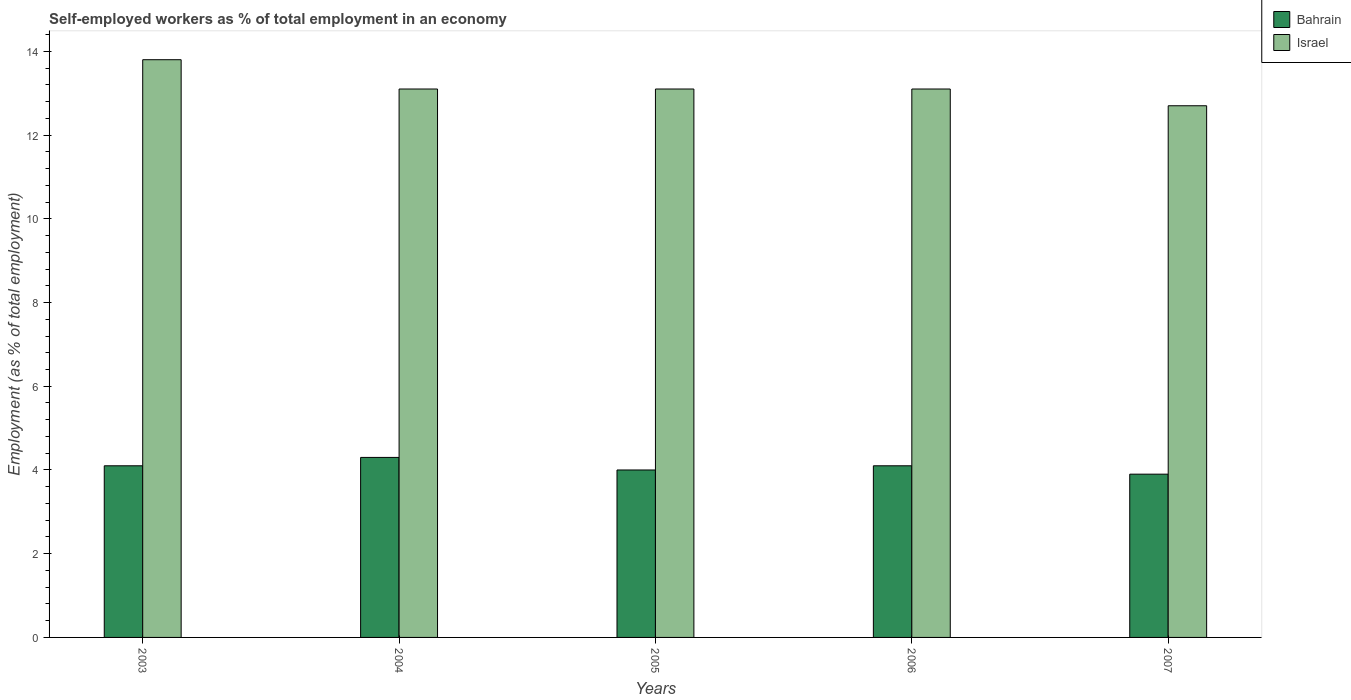Are the number of bars per tick equal to the number of legend labels?
Offer a very short reply. Yes. How many bars are there on the 1st tick from the left?
Your answer should be very brief. 2. What is the percentage of self-employed workers in Israel in 2003?
Provide a short and direct response. 13.8. Across all years, what is the maximum percentage of self-employed workers in Israel?
Provide a succinct answer. 13.8. Across all years, what is the minimum percentage of self-employed workers in Bahrain?
Give a very brief answer. 3.9. In which year was the percentage of self-employed workers in Bahrain maximum?
Give a very brief answer. 2004. In which year was the percentage of self-employed workers in Bahrain minimum?
Ensure brevity in your answer.  2007. What is the total percentage of self-employed workers in Bahrain in the graph?
Your response must be concise. 20.4. What is the difference between the percentage of self-employed workers in Bahrain in 2004 and that in 2007?
Offer a terse response. 0.4. What is the difference between the percentage of self-employed workers in Bahrain in 2007 and the percentage of self-employed workers in Israel in 2004?
Your response must be concise. -9.2. What is the average percentage of self-employed workers in Bahrain per year?
Ensure brevity in your answer.  4.08. In the year 2003, what is the difference between the percentage of self-employed workers in Israel and percentage of self-employed workers in Bahrain?
Your answer should be very brief. 9.7. What is the ratio of the percentage of self-employed workers in Bahrain in 2006 to that in 2007?
Offer a terse response. 1.05. Is the difference between the percentage of self-employed workers in Israel in 2003 and 2007 greater than the difference between the percentage of self-employed workers in Bahrain in 2003 and 2007?
Keep it short and to the point. Yes. What is the difference between the highest and the second highest percentage of self-employed workers in Israel?
Offer a very short reply. 0.7. What is the difference between the highest and the lowest percentage of self-employed workers in Bahrain?
Provide a short and direct response. 0.4. Is the sum of the percentage of self-employed workers in Israel in 2004 and 2007 greater than the maximum percentage of self-employed workers in Bahrain across all years?
Give a very brief answer. Yes. What does the 1st bar from the right in 2006 represents?
Your answer should be compact. Israel. How many years are there in the graph?
Your answer should be compact. 5. Does the graph contain any zero values?
Keep it short and to the point. No. Does the graph contain grids?
Give a very brief answer. No. Where does the legend appear in the graph?
Make the answer very short. Top right. How many legend labels are there?
Your response must be concise. 2. How are the legend labels stacked?
Your response must be concise. Vertical. What is the title of the graph?
Provide a short and direct response. Self-employed workers as % of total employment in an economy. Does "Burundi" appear as one of the legend labels in the graph?
Ensure brevity in your answer.  No. What is the label or title of the Y-axis?
Make the answer very short. Employment (as % of total employment). What is the Employment (as % of total employment) of Bahrain in 2003?
Offer a terse response. 4.1. What is the Employment (as % of total employment) of Israel in 2003?
Offer a very short reply. 13.8. What is the Employment (as % of total employment) in Bahrain in 2004?
Your answer should be very brief. 4.3. What is the Employment (as % of total employment) of Israel in 2004?
Your answer should be compact. 13.1. What is the Employment (as % of total employment) of Bahrain in 2005?
Your answer should be compact. 4. What is the Employment (as % of total employment) in Israel in 2005?
Provide a short and direct response. 13.1. What is the Employment (as % of total employment) in Bahrain in 2006?
Offer a very short reply. 4.1. What is the Employment (as % of total employment) in Israel in 2006?
Offer a terse response. 13.1. What is the Employment (as % of total employment) of Bahrain in 2007?
Your answer should be compact. 3.9. What is the Employment (as % of total employment) of Israel in 2007?
Keep it short and to the point. 12.7. Across all years, what is the maximum Employment (as % of total employment) of Bahrain?
Make the answer very short. 4.3. Across all years, what is the maximum Employment (as % of total employment) in Israel?
Provide a short and direct response. 13.8. Across all years, what is the minimum Employment (as % of total employment) in Bahrain?
Your answer should be compact. 3.9. Across all years, what is the minimum Employment (as % of total employment) of Israel?
Make the answer very short. 12.7. What is the total Employment (as % of total employment) of Bahrain in the graph?
Your response must be concise. 20.4. What is the total Employment (as % of total employment) of Israel in the graph?
Provide a succinct answer. 65.8. What is the difference between the Employment (as % of total employment) in Israel in 2003 and that in 2005?
Offer a very short reply. 0.7. What is the difference between the Employment (as % of total employment) in Israel in 2003 and that in 2006?
Your response must be concise. 0.7. What is the difference between the Employment (as % of total employment) of Bahrain in 2003 and that in 2007?
Give a very brief answer. 0.2. What is the difference between the Employment (as % of total employment) in Israel in 2004 and that in 2005?
Your response must be concise. 0. What is the difference between the Employment (as % of total employment) of Bahrain in 2004 and that in 2007?
Your answer should be very brief. 0.4. What is the difference between the Employment (as % of total employment) in Bahrain in 2005 and that in 2006?
Make the answer very short. -0.1. What is the difference between the Employment (as % of total employment) of Israel in 2005 and that in 2006?
Ensure brevity in your answer.  0. What is the difference between the Employment (as % of total employment) in Israel in 2005 and that in 2007?
Make the answer very short. 0.4. What is the difference between the Employment (as % of total employment) in Bahrain in 2003 and the Employment (as % of total employment) in Israel in 2004?
Offer a very short reply. -9. What is the difference between the Employment (as % of total employment) in Bahrain in 2003 and the Employment (as % of total employment) in Israel in 2005?
Give a very brief answer. -9. What is the difference between the Employment (as % of total employment) in Bahrain in 2003 and the Employment (as % of total employment) in Israel in 2007?
Provide a short and direct response. -8.6. What is the difference between the Employment (as % of total employment) of Bahrain in 2005 and the Employment (as % of total employment) of Israel in 2006?
Offer a very short reply. -9.1. What is the difference between the Employment (as % of total employment) in Bahrain in 2005 and the Employment (as % of total employment) in Israel in 2007?
Ensure brevity in your answer.  -8.7. What is the difference between the Employment (as % of total employment) in Bahrain in 2006 and the Employment (as % of total employment) in Israel in 2007?
Your response must be concise. -8.6. What is the average Employment (as % of total employment) in Bahrain per year?
Give a very brief answer. 4.08. What is the average Employment (as % of total employment) of Israel per year?
Your response must be concise. 13.16. In the year 2004, what is the difference between the Employment (as % of total employment) of Bahrain and Employment (as % of total employment) of Israel?
Provide a succinct answer. -8.8. In the year 2005, what is the difference between the Employment (as % of total employment) of Bahrain and Employment (as % of total employment) of Israel?
Provide a short and direct response. -9.1. In the year 2006, what is the difference between the Employment (as % of total employment) of Bahrain and Employment (as % of total employment) of Israel?
Your response must be concise. -9. What is the ratio of the Employment (as % of total employment) in Bahrain in 2003 to that in 2004?
Keep it short and to the point. 0.95. What is the ratio of the Employment (as % of total employment) of Israel in 2003 to that in 2004?
Make the answer very short. 1.05. What is the ratio of the Employment (as % of total employment) of Israel in 2003 to that in 2005?
Keep it short and to the point. 1.05. What is the ratio of the Employment (as % of total employment) in Bahrain in 2003 to that in 2006?
Your answer should be very brief. 1. What is the ratio of the Employment (as % of total employment) of Israel in 2003 to that in 2006?
Ensure brevity in your answer.  1.05. What is the ratio of the Employment (as % of total employment) of Bahrain in 2003 to that in 2007?
Offer a terse response. 1.05. What is the ratio of the Employment (as % of total employment) in Israel in 2003 to that in 2007?
Provide a short and direct response. 1.09. What is the ratio of the Employment (as % of total employment) of Bahrain in 2004 to that in 2005?
Make the answer very short. 1.07. What is the ratio of the Employment (as % of total employment) in Israel in 2004 to that in 2005?
Offer a terse response. 1. What is the ratio of the Employment (as % of total employment) of Bahrain in 2004 to that in 2006?
Provide a succinct answer. 1.05. What is the ratio of the Employment (as % of total employment) of Israel in 2004 to that in 2006?
Offer a terse response. 1. What is the ratio of the Employment (as % of total employment) in Bahrain in 2004 to that in 2007?
Your answer should be compact. 1.1. What is the ratio of the Employment (as % of total employment) in Israel in 2004 to that in 2007?
Your answer should be compact. 1.03. What is the ratio of the Employment (as % of total employment) in Bahrain in 2005 to that in 2006?
Offer a terse response. 0.98. What is the ratio of the Employment (as % of total employment) of Bahrain in 2005 to that in 2007?
Keep it short and to the point. 1.03. What is the ratio of the Employment (as % of total employment) in Israel in 2005 to that in 2007?
Your answer should be compact. 1.03. What is the ratio of the Employment (as % of total employment) of Bahrain in 2006 to that in 2007?
Offer a very short reply. 1.05. What is the ratio of the Employment (as % of total employment) of Israel in 2006 to that in 2007?
Your answer should be very brief. 1.03. What is the difference between the highest and the second highest Employment (as % of total employment) of Bahrain?
Your answer should be compact. 0.2. What is the difference between the highest and the lowest Employment (as % of total employment) in Bahrain?
Offer a very short reply. 0.4. What is the difference between the highest and the lowest Employment (as % of total employment) in Israel?
Provide a short and direct response. 1.1. 